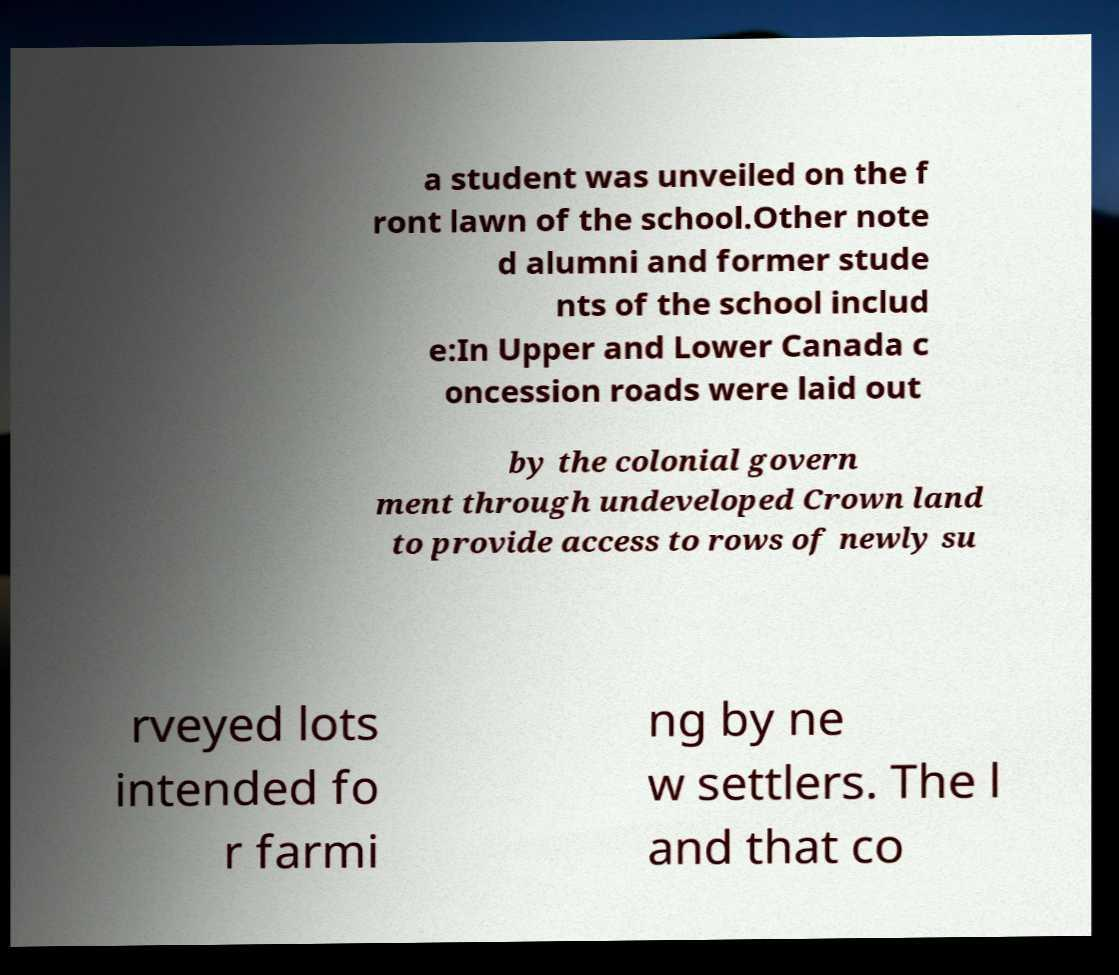Can you accurately transcribe the text from the provided image for me? a student was unveiled on the f ront lawn of the school.Other note d alumni and former stude nts of the school includ e:In Upper and Lower Canada c oncession roads were laid out by the colonial govern ment through undeveloped Crown land to provide access to rows of newly su rveyed lots intended fo r farmi ng by ne w settlers. The l and that co 